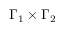<formula> <loc_0><loc_0><loc_500><loc_500>\Gamma _ { 1 } \times \Gamma _ { 2 }</formula> 